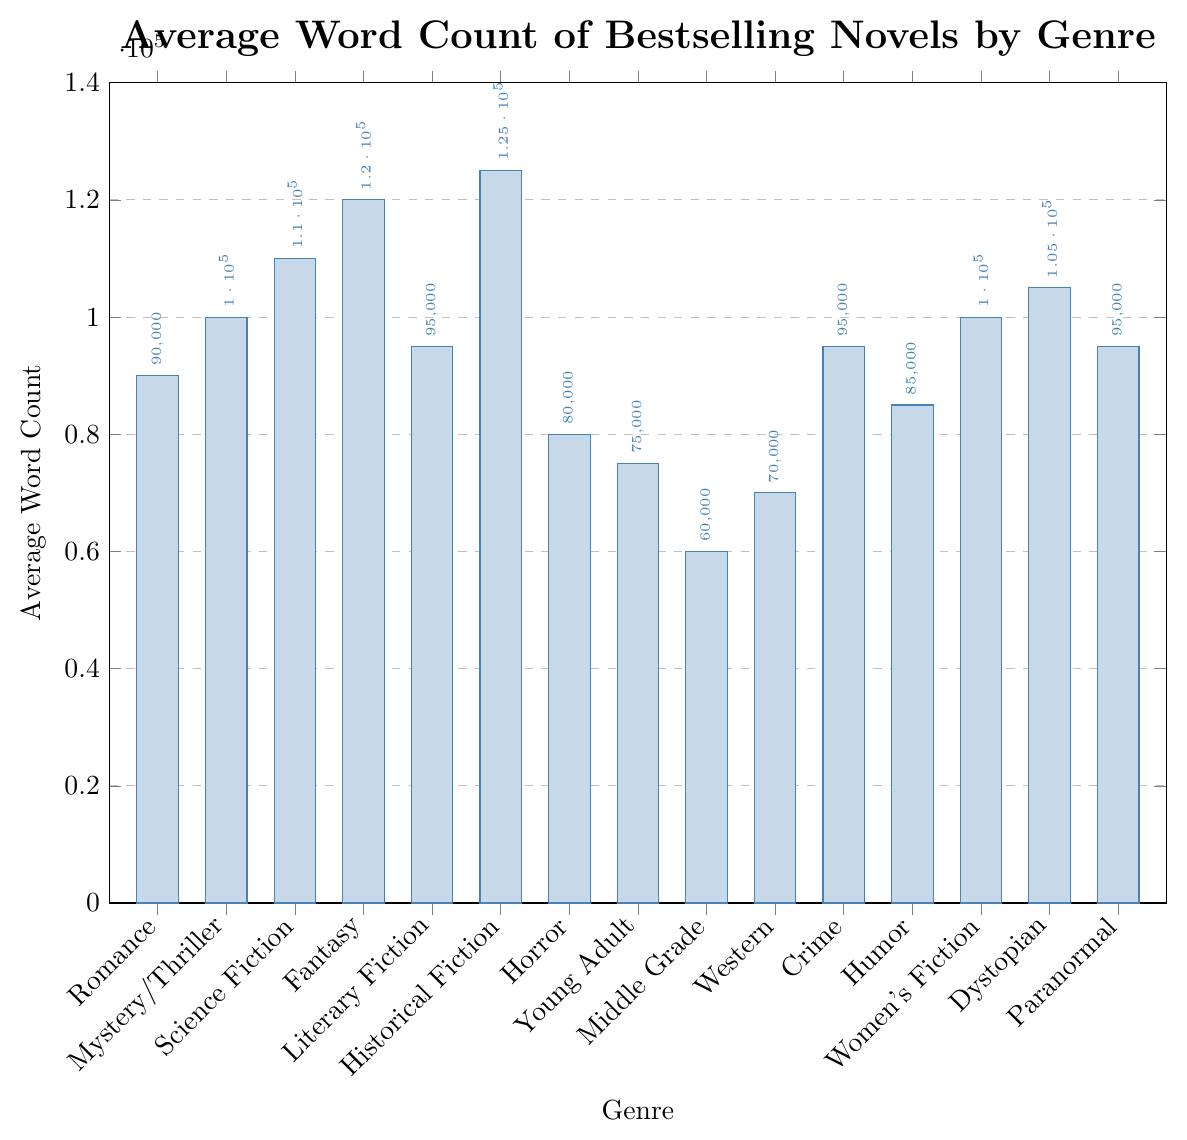Which genre has the highest average word count? The genre with the highest average word count is marked by the tallest bar in the bar chart. This genre is Historical Fiction with an average word count of 125,000.
Answer: Historical Fiction What is the difference in average word count between Fantasy and Horror genres? To calculate the difference, subtract the average word count of Horror (80,000) from Fantasy (120,000). The difference is 120,000 - 80,000
Answer: 40,000 Which genres have an average word count greater than 100,000? The genres with an average word count greater than 100,000 can be identified by the height of their bars relative to the 100,000 mark on the y-axis. These genres are Science Fiction, Fantasy, Historical Fiction, and Dystopian.
Answer: Science Fiction, Fantasy, Historical Fiction, Dystopian Is the average word count of Literary Fiction higher or lower than Women's Fiction? By comparing the height of the bars for Literary Fiction (95,000) and Women's Fiction (100,000), we see that the bar for Women's Fiction is taller, indicating a higher average word count.
Answer: Lower What's the combined average word count for Middle Grade and Young Adult genres? Sum the average word counts of Middle Grade (60,000) and Young Adult (75,000): 60,000 + 75,000
Answer: 135,000 Which genre has an average word count closest to 90,000? By examining the bars, Romance has an average word count of 90,000, which is exactly 90,000.
Answer: Romance How much higher is the average word count of Historical Fiction compared to Crime? Subtract the average word count of Crime (95,000) from Historical Fiction (125,000): 125,000 - 95,000
Answer: 30,000 What is the average word count range among all genres? To find the range, subtract the lowest average word count (Middle Grade: 60,000) from the highest (Historical Fiction: 125,000), resulting in a range of 125,000 - 60,000
Answer: 65,000 